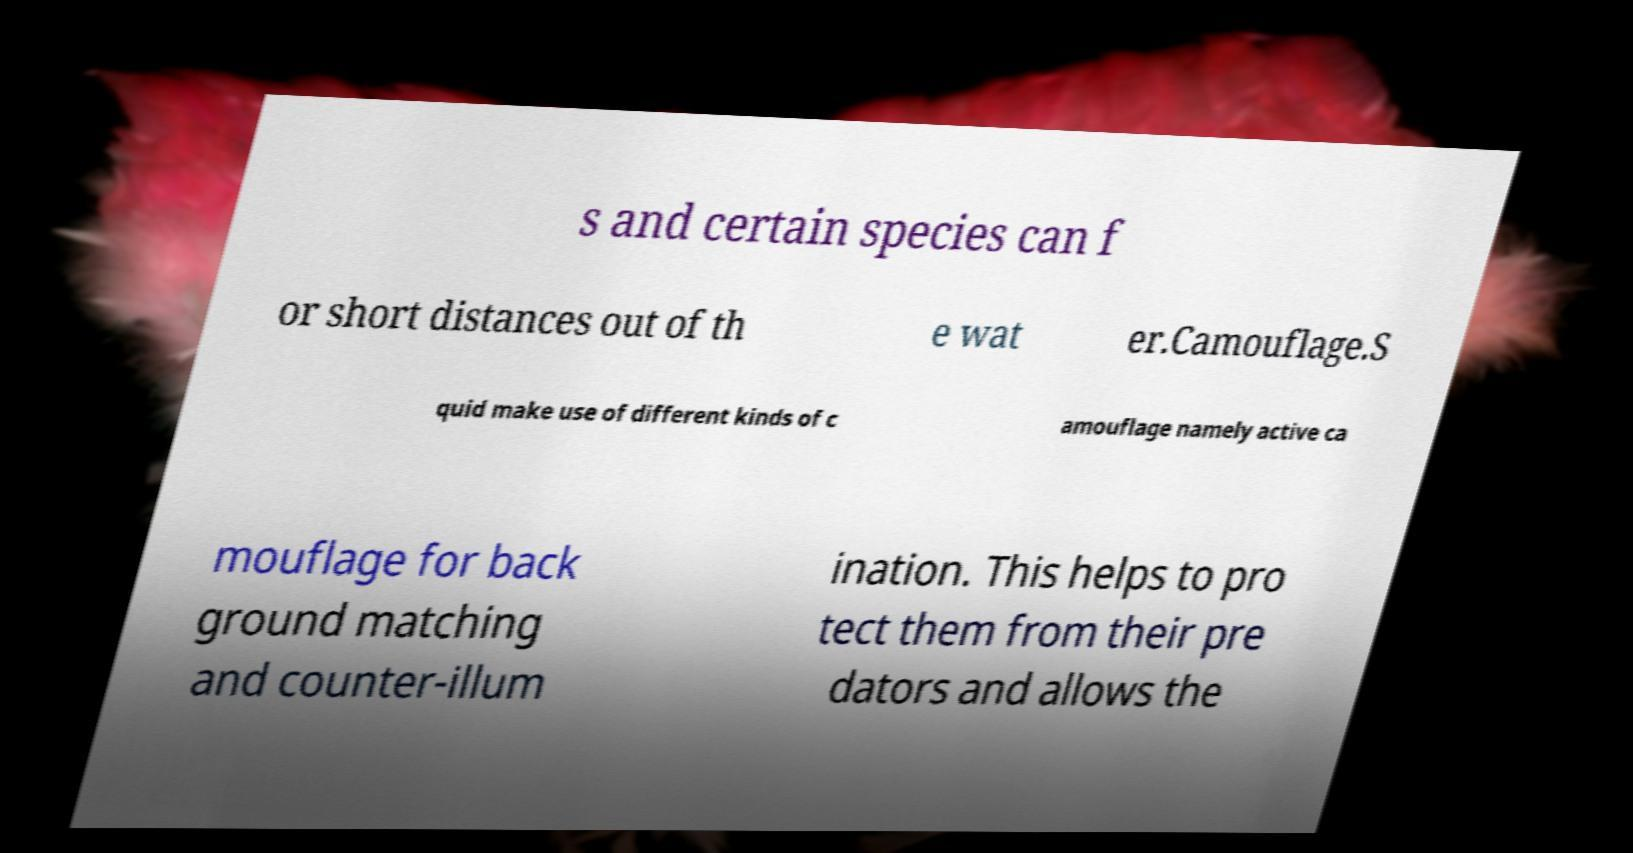What messages or text are displayed in this image? I need them in a readable, typed format. s and certain species can f or short distances out of th e wat er.Camouflage.S quid make use of different kinds of c amouflage namely active ca mouflage for back ground matching and counter-illum ination. This helps to pro tect them from their pre dators and allows the 